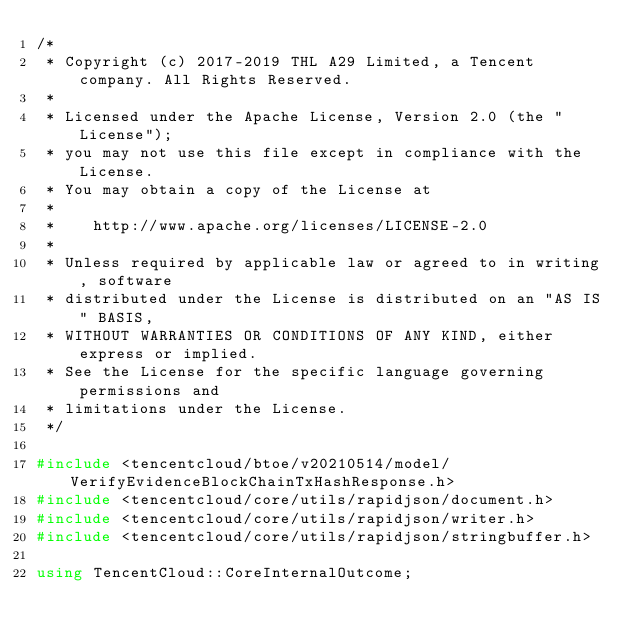<code> <loc_0><loc_0><loc_500><loc_500><_C++_>/*
 * Copyright (c) 2017-2019 THL A29 Limited, a Tencent company. All Rights Reserved.
 *
 * Licensed under the Apache License, Version 2.0 (the "License");
 * you may not use this file except in compliance with the License.
 * You may obtain a copy of the License at
 *
 *    http://www.apache.org/licenses/LICENSE-2.0
 *
 * Unless required by applicable law or agreed to in writing, software
 * distributed under the License is distributed on an "AS IS" BASIS,
 * WITHOUT WARRANTIES OR CONDITIONS OF ANY KIND, either express or implied.
 * See the License for the specific language governing permissions and
 * limitations under the License.
 */

#include <tencentcloud/btoe/v20210514/model/VerifyEvidenceBlockChainTxHashResponse.h>
#include <tencentcloud/core/utils/rapidjson/document.h>
#include <tencentcloud/core/utils/rapidjson/writer.h>
#include <tencentcloud/core/utils/rapidjson/stringbuffer.h>

using TencentCloud::CoreInternalOutcome;</code> 